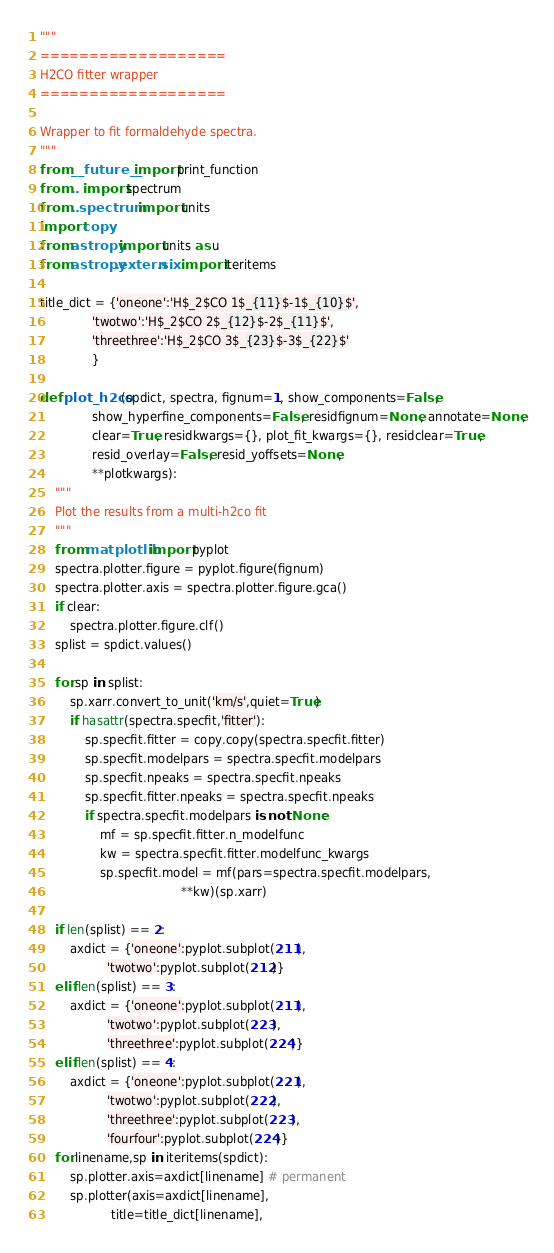Convert code to text. <code><loc_0><loc_0><loc_500><loc_500><_Python_>"""
===================
H2CO fitter wrapper
===================

Wrapper to fit formaldehyde spectra.
"""
from __future__ import print_function
from .. import spectrum
from ..spectrum import units
import copy
from astropy import units as u
from astropy.extern.six import iteritems

title_dict = {'oneone':'H$_2$CO 1$_{11}$-1$_{10}$',
              'twotwo':'H$_2$CO 2$_{12}$-2$_{11}$',
              'threethree':'H$_2$CO 3$_{23}$-3$_{22}$'
              }

def plot_h2co(spdict, spectra, fignum=1, show_components=False,
              show_hyperfine_components=False, residfignum=None, annotate=None,
              clear=True, residkwargs={}, plot_fit_kwargs={}, residclear=True,
              resid_overlay=False, resid_yoffsets=None,
              **plotkwargs):
    """
    Plot the results from a multi-h2co fit
    """
    from matplotlib import pyplot
    spectra.plotter.figure = pyplot.figure(fignum)
    spectra.plotter.axis = spectra.plotter.figure.gca()
    if clear:
        spectra.plotter.figure.clf()
    splist = spdict.values()

    for sp in splist:
        sp.xarr.convert_to_unit('km/s',quiet=True)
        if hasattr(spectra.specfit,'fitter'):
            sp.specfit.fitter = copy.copy(spectra.specfit.fitter)
            sp.specfit.modelpars = spectra.specfit.modelpars
            sp.specfit.npeaks = spectra.specfit.npeaks
            sp.specfit.fitter.npeaks = spectra.specfit.npeaks
            if spectra.specfit.modelpars is not None:
                mf = sp.specfit.fitter.n_modelfunc
                kw = spectra.specfit.fitter.modelfunc_kwargs
                sp.specfit.model = mf(pars=spectra.specfit.modelpars,
                                      **kw)(sp.xarr)

    if len(splist) == 2:
        axdict = {'oneone':pyplot.subplot(211),
                  'twotwo':pyplot.subplot(212)}
    elif len(splist) == 3:
        axdict = {'oneone':pyplot.subplot(211),
                  'twotwo':pyplot.subplot(223),
                  'threethree':pyplot.subplot(224)}
    elif len(splist) == 4:
        axdict = {'oneone':pyplot.subplot(221),
                  'twotwo':pyplot.subplot(222),
                  'threethree':pyplot.subplot(223),
                  'fourfour':pyplot.subplot(224)}
    for linename,sp in iteritems(spdict):
        sp.plotter.axis=axdict[linename] # permanent
        sp.plotter(axis=axdict[linename],
                   title=title_dict[linename],</code> 